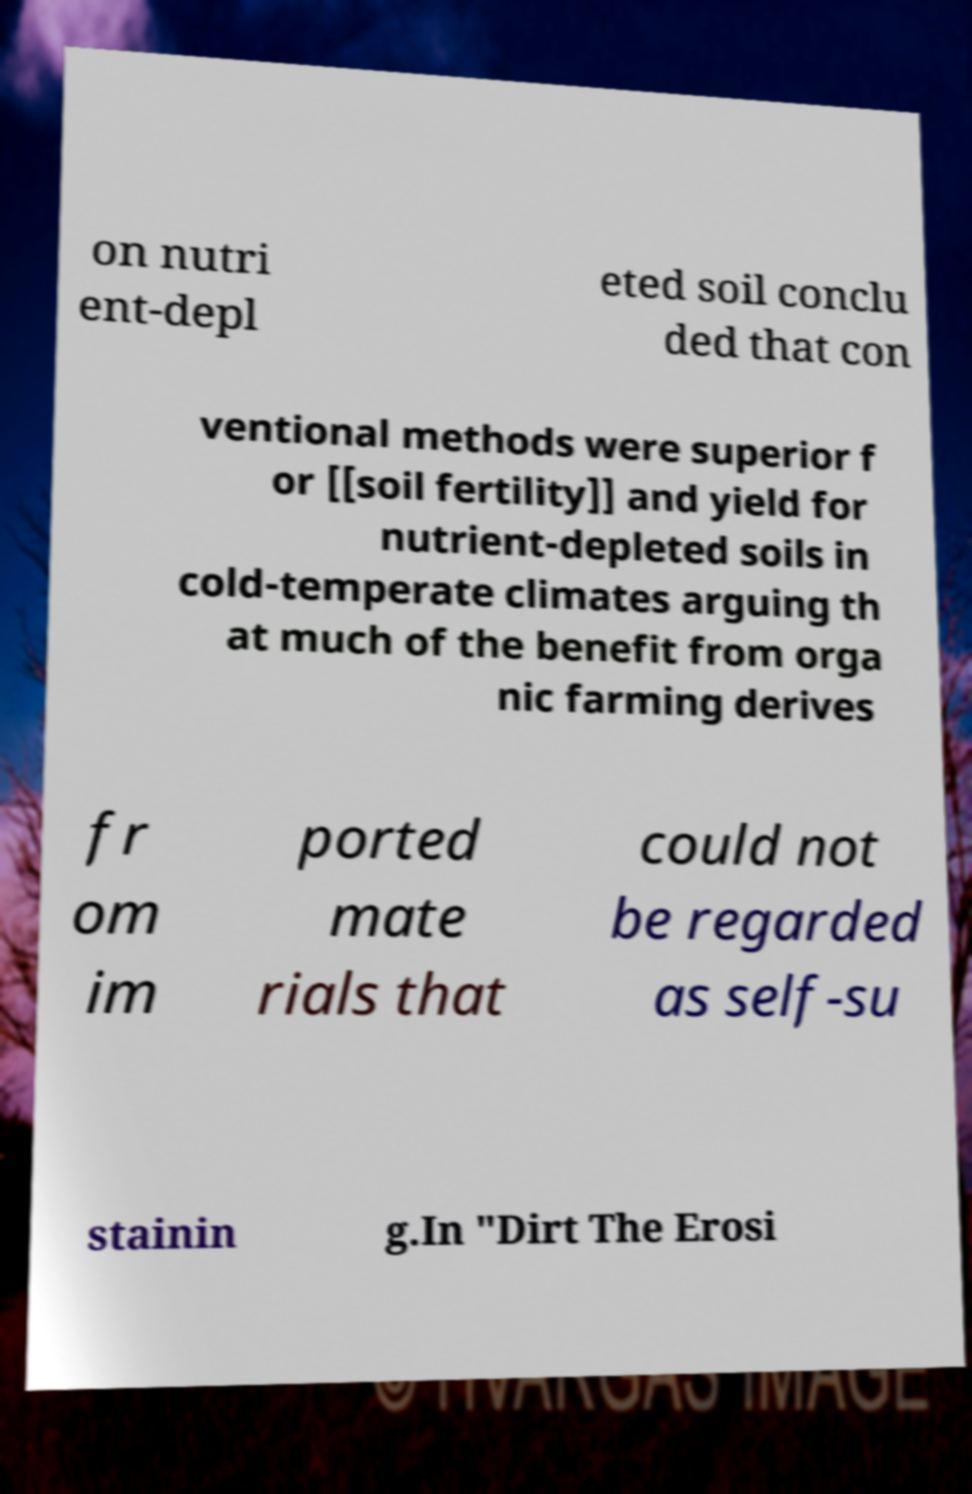Can you read and provide the text displayed in the image?This photo seems to have some interesting text. Can you extract and type it out for me? on nutri ent-depl eted soil conclu ded that con ventional methods were superior f or [[soil fertility]] and yield for nutrient-depleted soils in cold-temperate climates arguing th at much of the benefit from orga nic farming derives fr om im ported mate rials that could not be regarded as self-su stainin g.In "Dirt The Erosi 